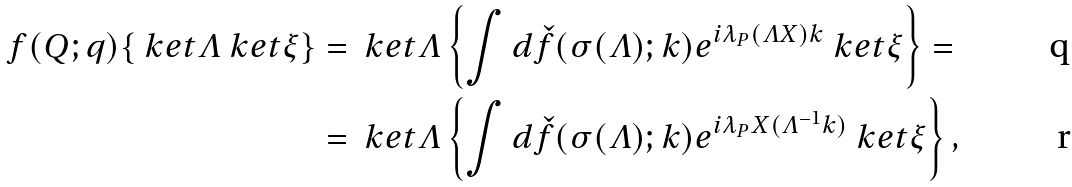<formula> <loc_0><loc_0><loc_500><loc_500>f ( Q ; q ) \{ \ k e t \varLambda \ k e t \xi \} & = \ k e t \varLambda \left \{ \int d \check { f } ( \sigma { ( \varLambda ) } ; k ) e ^ { i \lambda _ { P } ( \varLambda X ) k } \ k e t \xi \right \} = \\ & = \ k e t \varLambda \left \{ \int d \check { f } ( \sigma { ( \varLambda ) } ; k ) e ^ { i \lambda _ { P } X ( \varLambda ^ { - 1 } k ) } \ k e t \xi \right \} ,</formula> 